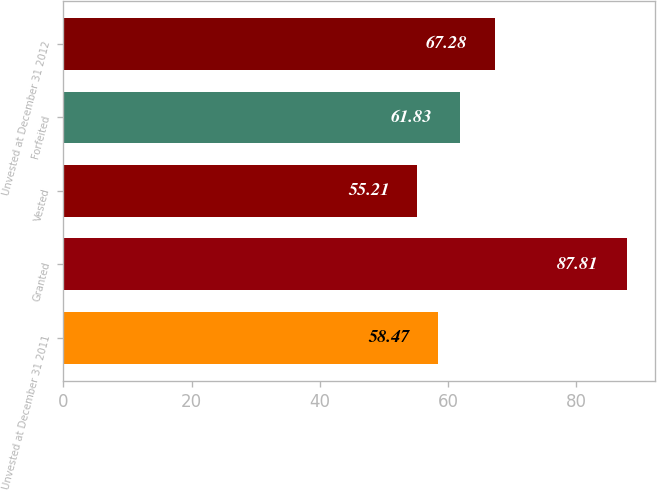<chart> <loc_0><loc_0><loc_500><loc_500><bar_chart><fcel>Unvested at December 31 2011<fcel>Granted<fcel>Vested<fcel>Forfeited<fcel>Unvested at December 31 2012<nl><fcel>58.47<fcel>87.81<fcel>55.21<fcel>61.83<fcel>67.28<nl></chart> 